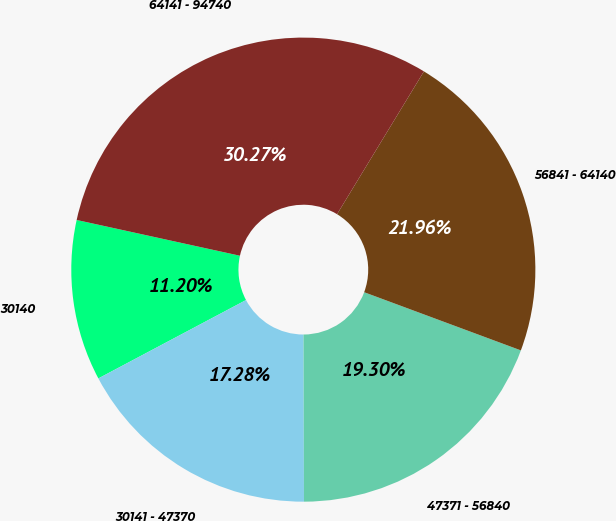<chart> <loc_0><loc_0><loc_500><loc_500><pie_chart><fcel>30140<fcel>30141 - 47370<fcel>47371 - 56840<fcel>56841 - 64140<fcel>64141 - 94740<nl><fcel>11.2%<fcel>17.28%<fcel>19.3%<fcel>21.96%<fcel>30.27%<nl></chart> 